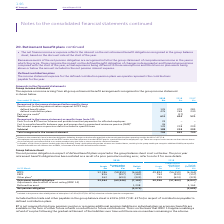According to Bt Group Plc's financial document, What was the result of the closure of the BTPS on the employees? All employees impacted by the closure of the BTPS receive transition payments into their BTRSS pot for a period linked to the employee’s age.. The document states: "nsion plans operating outside the UK in 2017/18. b All employees impacted by the closure of the BTPS receive transition payments into their BTRSS pot ..." Also, Why was there no past service cost or credit on closure of the BTPS? There was no past service cost or credit on closure due to the assumed past service benefit link as an active member being the same as that assumed for a deferred member.. The document states: "RSS pot for a period linked to the employee’s age. There was no past service cost or credit on closure due to the assumed past service benefit link as..." Also, What was the  Total recognised in the income statement for 2019? According to the financial document, 799 (in millions). The relevant text states: "Total recognised in the income statement 799 842 730..." Also, can you calculate: What is the change in defined benefit plans from 2019 to 2018? Based on the calculation: 135-376, the result is -241 (in millions). This is based on the information: "n expenses & PPF levy): defined benefit plans 135 376 281 defined contribution plans 476 265 240 Past service credit a – (17) – Subtotal 611 624 521 ation expenses & PPF levy): defined benefit plans 1..." The key data points involved are: 135, 376. Also, can you calculate: What is the change in defined contribution plans from 2019 to 2018? Based on the calculation: 476-265, the result is 211 (in millions). This is based on the information: "plans 135 376 281 defined contribution plans 476 265 240 Past service credit a – (17) – Subtotal 611 624 521 efit plans 135 376 281 defined contribution plans 476 265 240 Past service credit a – (17) ..." The key data points involved are: 265, 476. Also, can you calculate: What is the change in Total recognised in the income statement from 2019 to 2018? Based on the calculation: 799-842, the result is -43 (in millions). This is based on the information: "Total recognised in the income statement 799 842 730 Total recognised in the income statement 799 842 730..." The key data points involved are: 799, 842. 